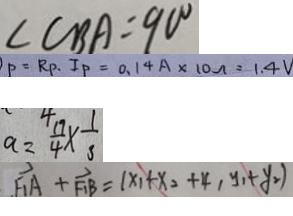Convert formula to latex. <formula><loc_0><loc_0><loc_500><loc_500>\angle C B A = 9 0 ^ { \circ } 
 P = R _ { P } . I _ { P } = 0 . 1 4 A \times 1 0 \Omega = 1 . 4 V 
 a = \frac { 1 9 } { 4 } \times \frac { 1 } { 3 } 
 F _ { 1 } A + F _ { 1 } B = ( x _ { 1 } + x _ { 2 } + 4 , y _ { 1 } + y _ { 2 } )</formula> 